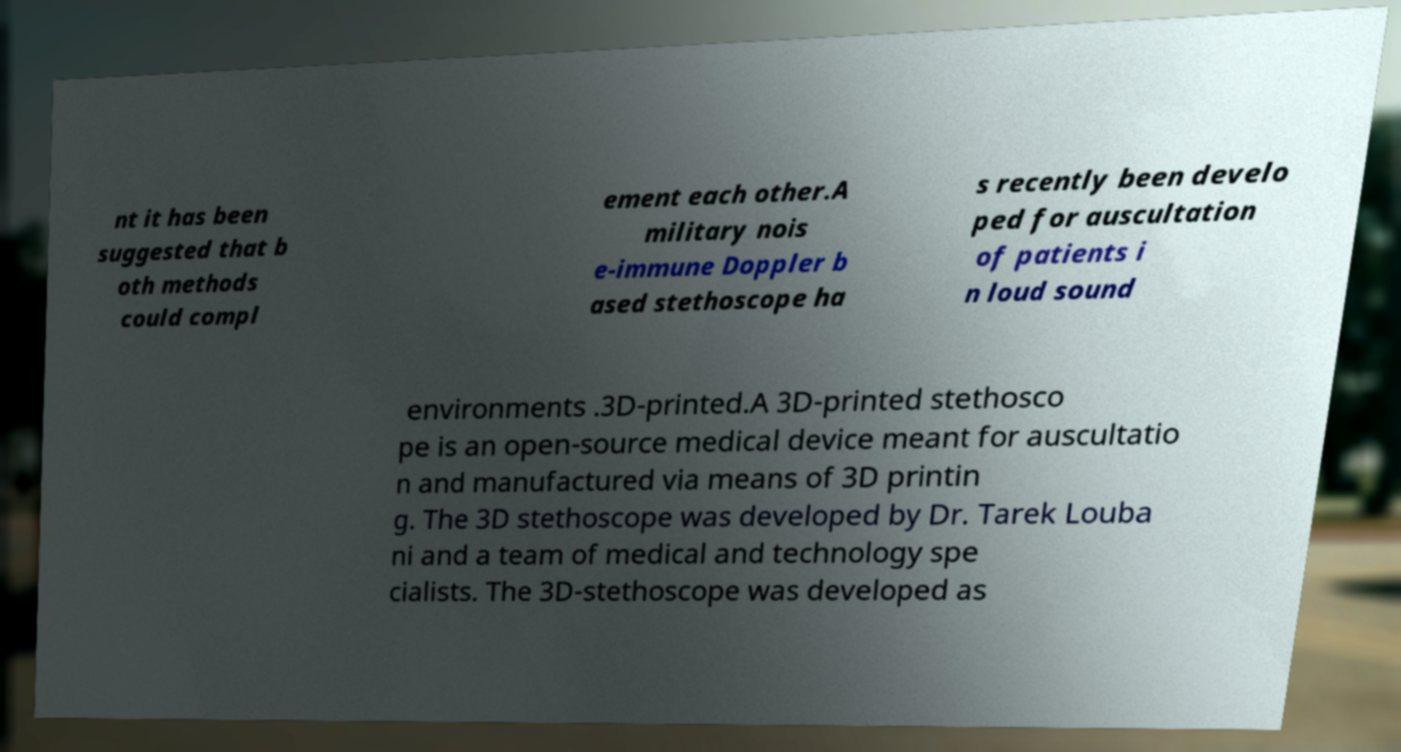I need the written content from this picture converted into text. Can you do that? nt it has been suggested that b oth methods could compl ement each other.A military nois e-immune Doppler b ased stethoscope ha s recently been develo ped for auscultation of patients i n loud sound environments .3D-printed.A 3D-printed stethosco pe is an open-source medical device meant for auscultatio n and manufactured via means of 3D printin g. The 3D stethoscope was developed by Dr. Tarek Louba ni and a team of medical and technology spe cialists. The 3D-stethoscope was developed as 